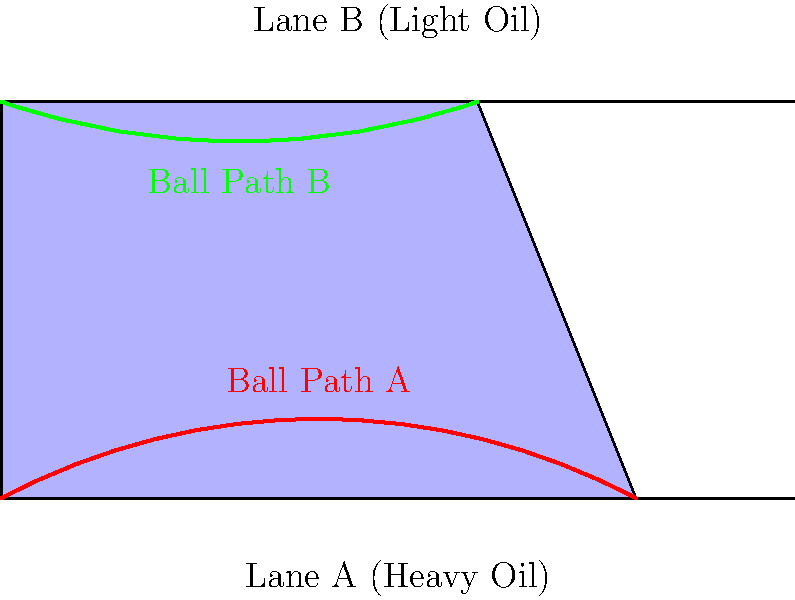Based on the oil pattern graphs for Lane A and Lane B, which lane is more likely to produce a higher hook potential for a right-handed bowler, and why? To answer this question, we need to analyze the oil patterns and their effect on ball movement:

1. Lane A (Heavy Oil):
   - The oil pattern extends further down the lane
   - The oil is more evenly distributed
   - This creates less friction for the ball initially

2. Lane B (Light Oil):
   - The oil pattern is shorter and tapers more quickly
   - There's less oil overall, especially towards the end of the lane
   - This creates more friction for the ball, especially in the backend

3. Hook potential:
   - Hook is created when the ball transitions from sliding to rolling
   - More friction allows for earlier and more pronounced hook

4. Analysis for a right-handed bowler:
   - On Lane A, the ball will slide further before hooking
   - On Lane B, the ball will encounter more friction earlier, allowing for earlier and potentially more hook

5. Conclusion:
   Lane B is more likely to produce a higher hook potential because:
   - The lighter oil condition creates more friction
   - The ball will transition from sliding to rolling earlier
   - This earlier transition allows for more time and space for the ball to hook

As a professional bowler, understanding these patterns helps in adjusting your throw and choosing the right ball to maximize your scoring potential on different lane conditions.
Answer: Lane B (Light Oil) 